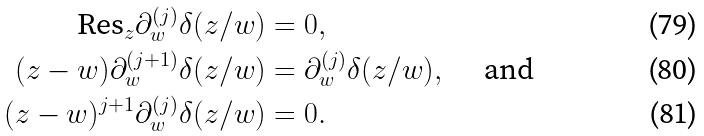<formula> <loc_0><loc_0><loc_500><loc_500>\text {Res} _ { z } \partial _ { w } ^ { ( j ) } \delta ( z / w ) & = 0 , \\ ( z - w ) \partial ^ { ( j + 1 ) } _ { w } \delta ( z / w ) & = \partial ^ { ( j ) } _ { w } \delta ( z / w ) , \quad \text { and} \\ ( z - w ) ^ { j + 1 } \partial ^ { ( j ) } _ { w } \delta ( z / w ) & = 0 .</formula> 